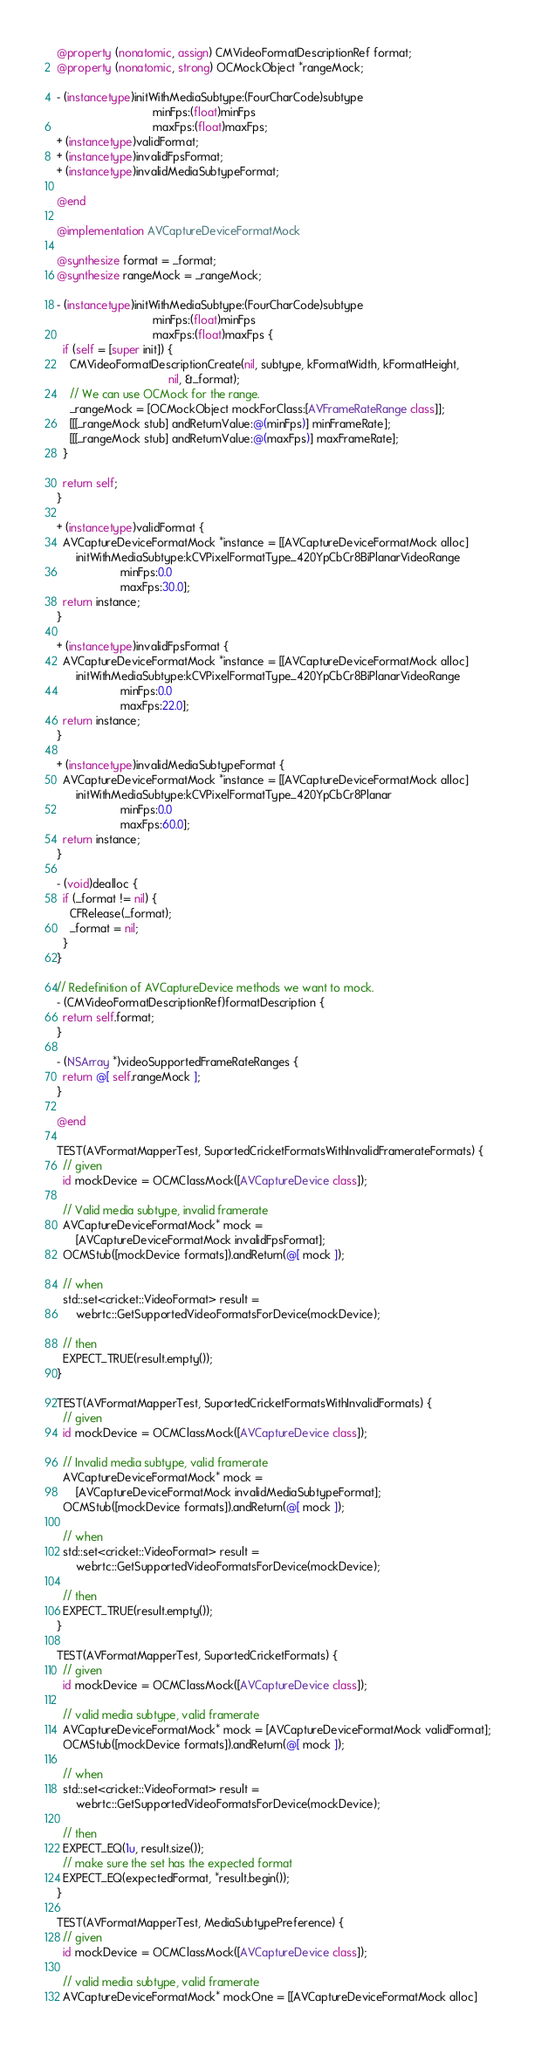<code> <loc_0><loc_0><loc_500><loc_500><_ObjectiveC_>
@property (nonatomic, assign) CMVideoFormatDescriptionRef format;
@property (nonatomic, strong) OCMockObject *rangeMock;

- (instancetype)initWithMediaSubtype:(FourCharCode)subtype
                              minFps:(float)minFps
                              maxFps:(float)maxFps;
+ (instancetype)validFormat;
+ (instancetype)invalidFpsFormat;
+ (instancetype)invalidMediaSubtypeFormat;

@end

@implementation AVCaptureDeviceFormatMock

@synthesize format = _format;
@synthesize rangeMock = _rangeMock;

- (instancetype)initWithMediaSubtype:(FourCharCode)subtype
                              minFps:(float)minFps
                              maxFps:(float)maxFps {
  if (self = [super init]) {
    CMVideoFormatDescriptionCreate(nil, subtype, kFormatWidth, kFormatHeight,
                                   nil, &_format);
    // We can use OCMock for the range.
    _rangeMock = [OCMockObject mockForClass:[AVFrameRateRange class]];
    [[[_rangeMock stub] andReturnValue:@(minFps)] minFrameRate];
    [[[_rangeMock stub] andReturnValue:@(maxFps)] maxFrameRate];
  }

  return self;
}

+ (instancetype)validFormat {
  AVCaptureDeviceFormatMock *instance = [[AVCaptureDeviceFormatMock alloc]
      initWithMediaSubtype:kCVPixelFormatType_420YpCbCr8BiPlanarVideoRange
                    minFps:0.0
                    maxFps:30.0];
  return instance;
}

+ (instancetype)invalidFpsFormat {
  AVCaptureDeviceFormatMock *instance = [[AVCaptureDeviceFormatMock alloc]
      initWithMediaSubtype:kCVPixelFormatType_420YpCbCr8BiPlanarVideoRange
                    minFps:0.0
                    maxFps:22.0];
  return instance;
}

+ (instancetype)invalidMediaSubtypeFormat {
  AVCaptureDeviceFormatMock *instance = [[AVCaptureDeviceFormatMock alloc]
      initWithMediaSubtype:kCVPixelFormatType_420YpCbCr8Planar
                    minFps:0.0
                    maxFps:60.0];
  return instance;
}

- (void)dealloc {
  if (_format != nil) {
    CFRelease(_format);
    _format = nil;
  }
}

// Redefinition of AVCaptureDevice methods we want to mock.
- (CMVideoFormatDescriptionRef)formatDescription {
  return self.format;
}

- (NSArray *)videoSupportedFrameRateRanges {
  return @[ self.rangeMock ];
}

@end

TEST(AVFormatMapperTest, SuportedCricketFormatsWithInvalidFramerateFormats) {
  // given
  id mockDevice = OCMClassMock([AVCaptureDevice class]);

  // Valid media subtype, invalid framerate
  AVCaptureDeviceFormatMock* mock =
      [AVCaptureDeviceFormatMock invalidFpsFormat];
  OCMStub([mockDevice formats]).andReturn(@[ mock ]);

  // when
  std::set<cricket::VideoFormat> result =
      webrtc::GetSupportedVideoFormatsForDevice(mockDevice);

  // then
  EXPECT_TRUE(result.empty());
}

TEST(AVFormatMapperTest, SuportedCricketFormatsWithInvalidFormats) {
  // given
  id mockDevice = OCMClassMock([AVCaptureDevice class]);

  // Invalid media subtype, valid framerate
  AVCaptureDeviceFormatMock* mock =
      [AVCaptureDeviceFormatMock invalidMediaSubtypeFormat];
  OCMStub([mockDevice formats]).andReturn(@[ mock ]);

  // when
  std::set<cricket::VideoFormat> result =
      webrtc::GetSupportedVideoFormatsForDevice(mockDevice);

  // then
  EXPECT_TRUE(result.empty());
}

TEST(AVFormatMapperTest, SuportedCricketFormats) {
  // given
  id mockDevice = OCMClassMock([AVCaptureDevice class]);

  // valid media subtype, valid framerate
  AVCaptureDeviceFormatMock* mock = [AVCaptureDeviceFormatMock validFormat];
  OCMStub([mockDevice formats]).andReturn(@[ mock ]);

  // when
  std::set<cricket::VideoFormat> result =
      webrtc::GetSupportedVideoFormatsForDevice(mockDevice);

  // then
  EXPECT_EQ(1u, result.size());
  // make sure the set has the expected format
  EXPECT_EQ(expectedFormat, *result.begin());
}

TEST(AVFormatMapperTest, MediaSubtypePreference) {
  // given
  id mockDevice = OCMClassMock([AVCaptureDevice class]);

  // valid media subtype, valid framerate
  AVCaptureDeviceFormatMock* mockOne = [[AVCaptureDeviceFormatMock alloc]</code> 